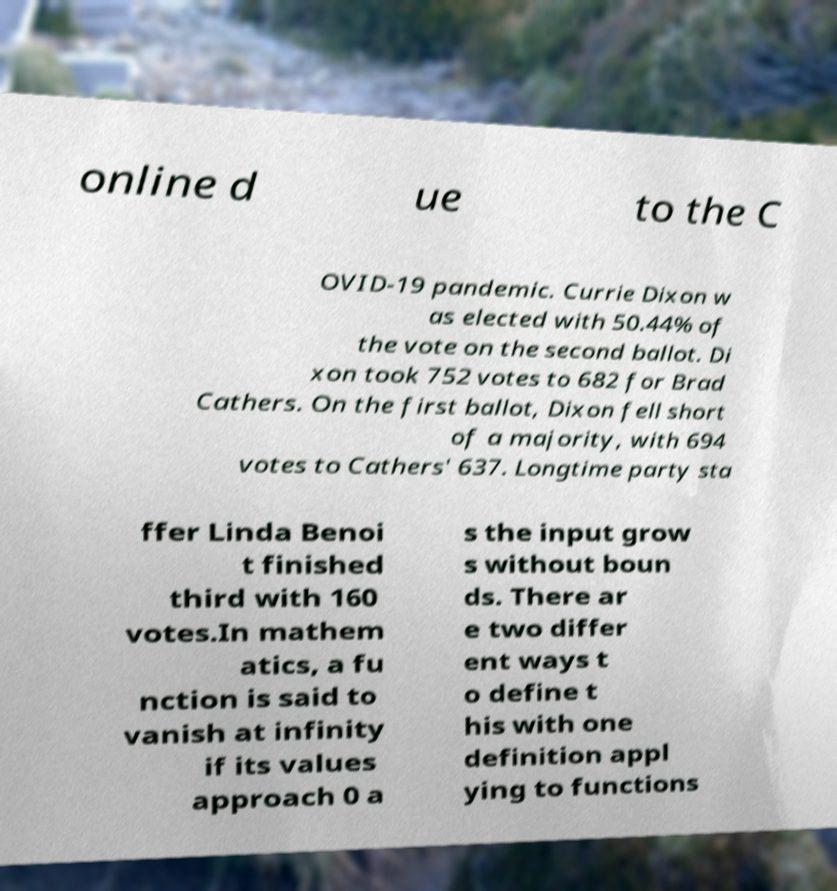Can you accurately transcribe the text from the provided image for me? online d ue to the C OVID-19 pandemic. Currie Dixon w as elected with 50.44% of the vote on the second ballot. Di xon took 752 votes to 682 for Brad Cathers. On the first ballot, Dixon fell short of a majority, with 694 votes to Cathers' 637. Longtime party sta ffer Linda Benoi t finished third with 160 votes.In mathem atics, a fu nction is said to vanish at infinity if its values approach 0 a s the input grow s without boun ds. There ar e two differ ent ways t o define t his with one definition appl ying to functions 